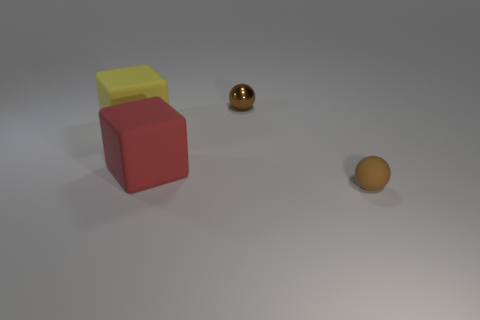There is another thing that is the same color as the small metallic thing; what shape is it?
Make the answer very short. Sphere. Is the shape of the big red thing the same as the small brown object in front of the small brown metallic object?
Provide a short and direct response. No. What is the material of the big thing to the left of the big matte thing that is in front of the cube on the left side of the red cube?
Provide a short and direct response. Rubber. How many large things are yellow matte objects or matte blocks?
Offer a terse response. 2. How many other things are the same size as the yellow block?
Offer a very short reply. 1. There is a brown thing on the right side of the small shiny sphere; is it the same shape as the red thing?
Give a very brief answer. No. There is a small rubber thing that is the same shape as the tiny brown metallic object; what color is it?
Your answer should be compact. Brown. Is there any other thing that has the same shape as the small shiny thing?
Give a very brief answer. Yes. Is the number of tiny objects to the left of the yellow matte object the same as the number of tiny shiny balls?
Ensure brevity in your answer.  No. How many objects are both left of the small brown matte object and in front of the red block?
Provide a succinct answer. 0. 